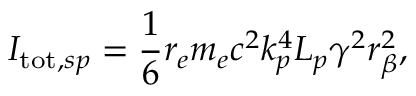<formula> <loc_0><loc_0><loc_500><loc_500>I _ { t o t , s p } = \frac { 1 } { 6 } r _ { e } m _ { e } c ^ { 2 } k _ { p } ^ { 4 } L _ { p } \gamma ^ { 2 } r _ { \beta } ^ { 2 } ,</formula> 